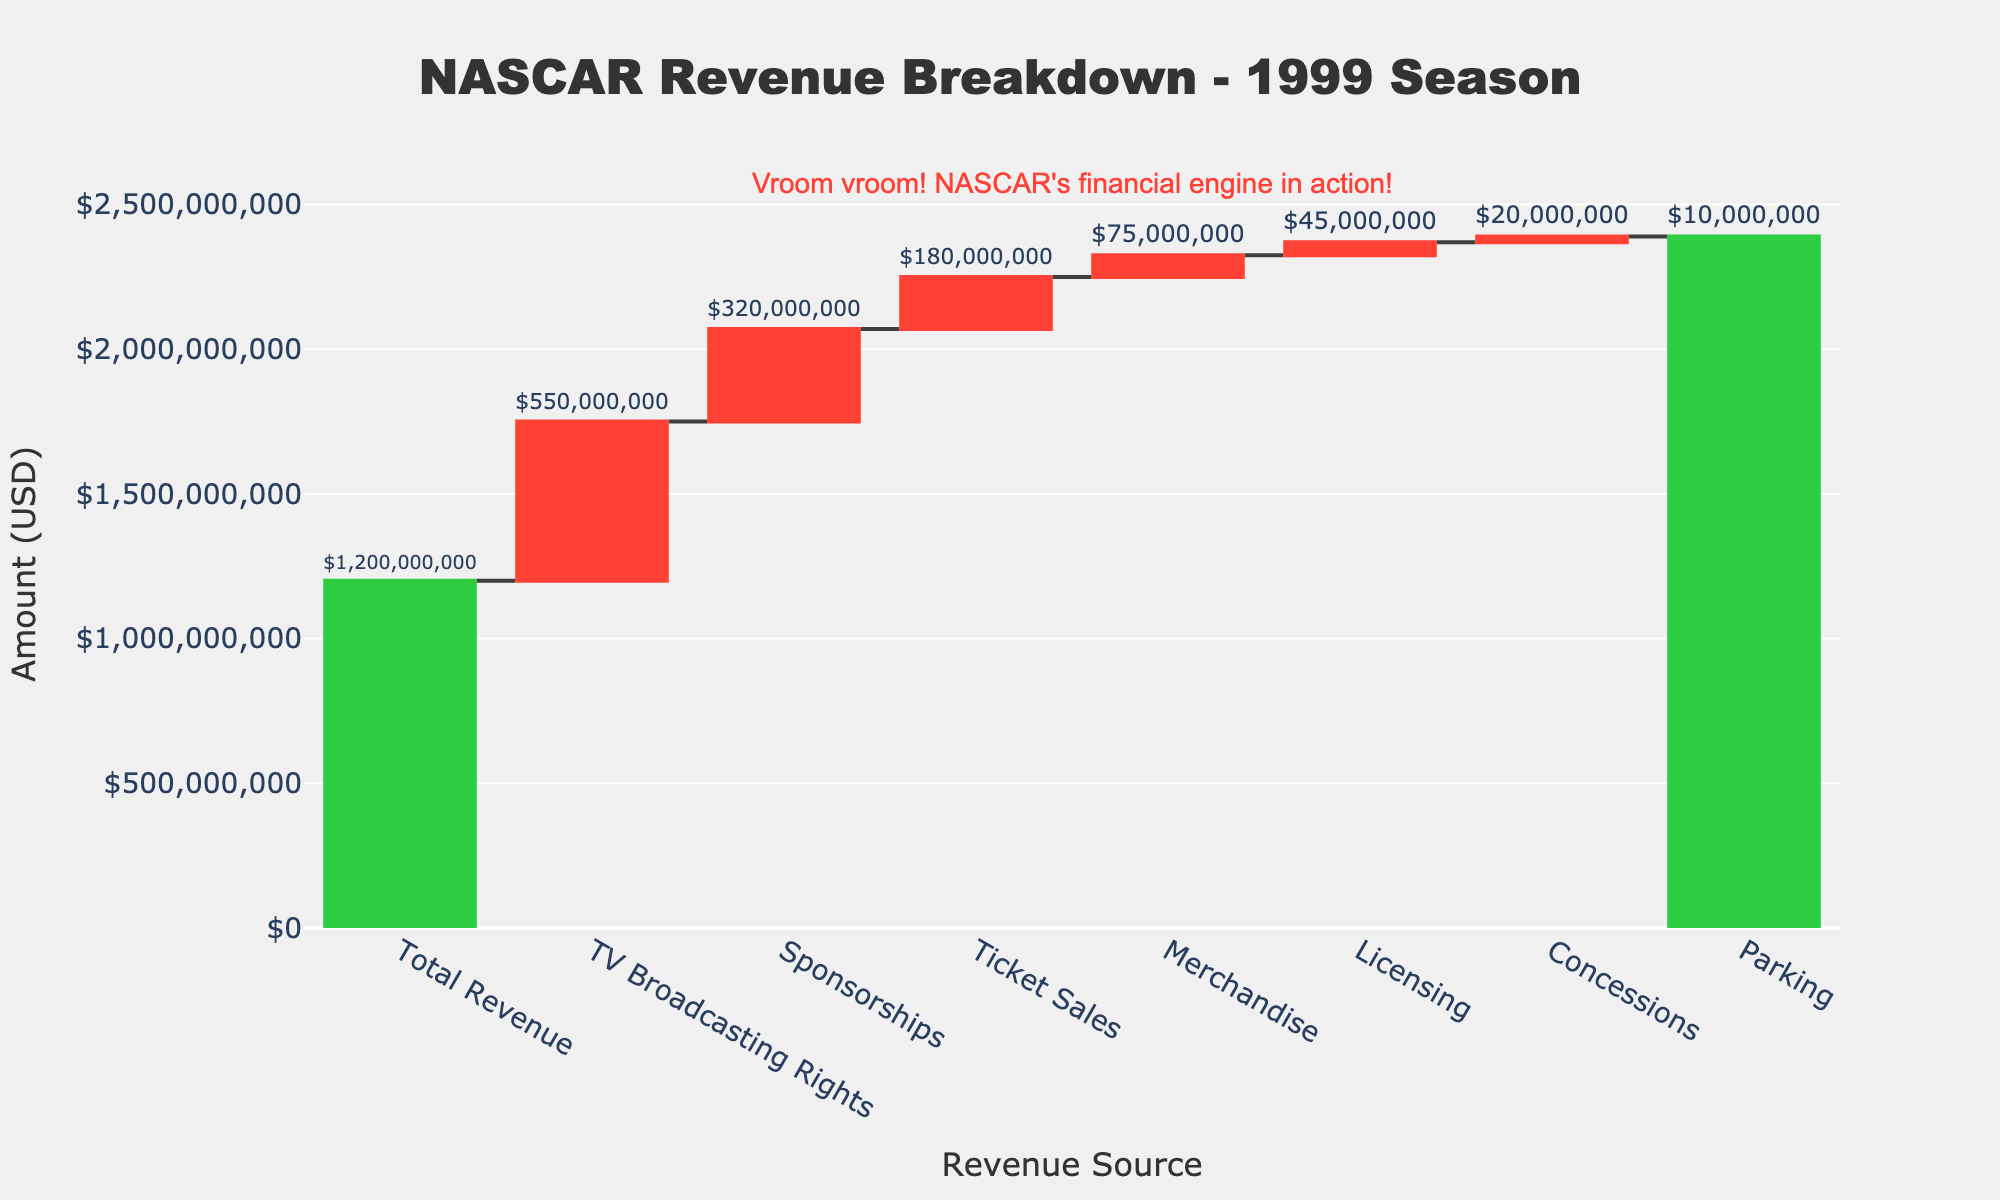What's the title of the chart? The title is displayed at the top of the chart.
Answer: NASCAR Revenue Breakdown - 1999 Season What are the categories listed on the x-axis? The x-axis shows the different revenue sources listed as categories. They are: "Total Revenue," "TV Broadcasting Rights," "Sponsorships," "Ticket Sales," "Merchandise," "Licensing," "Concessions," and "Parking."
Answer: Total Revenue, TV Broadcasting Rights, Sponsorships, Ticket Sales, Merchandise, Licensing, Concessions, Parking What is the color used for the 'Total' revenue bar? The 'Total Revenue' bar uses green, indicating it’s a total measure.
Answer: Green Which revenue source has the highest value? By comparing the height of the bars, "TV Broadcasting Rights" has the highest value.
Answer: TV Broadcasting Rights How much revenue did 'Sponsorships' generate in 1999? The bar for "Sponsorships" shows the value when hovered over, displayed as "$320,000,000."
Answer: $320,000,000 What is the combined revenue from 'Merchandise' and 'Licensing'? The values for "Merchandise" and "Licensing" are $75,000,000 and $45,000,000 respectively. Adding these together gives $120,000,000.
Answer: $120,000,000 Which source generated less revenue: 'Concessions' or 'Parking'? Comparing the bar heights, "Parking" generated $10,000,000, and "Concessions" generated $20,000,000. Therefore, "Parking" generated less.
Answer: Parking What is the sum of all non-'Total' revenue sources? Adding all the values for non-'Total' entries: $550,000,000 (TV Broadcasting Rights) + $320,000,000 (Sponsorships) + $180,000,000 (Ticket Sales) + $75,000,000 (Merchandise) + $45,000,000 (Licensing) + $20,000,000 (Concessions) + $10,000,000 (Parking) = $1,200,000,000.
Answer: $1,200,000,000 How does the 'Ticket Sales' revenue compare to the combined revenue of 'Concessions' and 'Parking'? The revenue from "Ticket Sales" is $180,000,000. The combined revenue from "Concessions" and "Parking" is $30,000,000 ($20,000,000 + $10,000,000). "$180,000,000" is much higher than "$30,000,000".
Answer: Ticket Sales is higher than the combined amount What is the difference in revenue between 'TV Broadcasting Rights' and 'Sponsorships'? The values for "TV Broadcasting Rights" and "Sponsorships" are $550,000,000 and $320,000,000 respectively. Subtracting these gives a difference of $230,000,000.
Answer: $230,000,000 